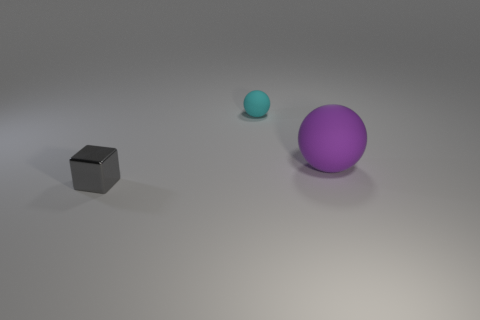Imagine if these objects were part of a game, what kind of game could it be? If these objects were part of a game, it might be a physics puzzle game. Players could solve challenges by moving the objects to specific locations, perhaps fitting the cube into a slot or rolling the balls to hit targets, using properties like weight and friction as puzzle elements. 